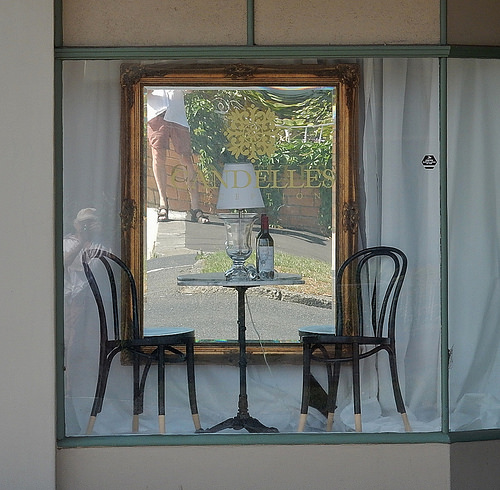<image>
Can you confirm if the bottle is next to the chair? Yes. The bottle is positioned adjacent to the chair, located nearby in the same general area. 